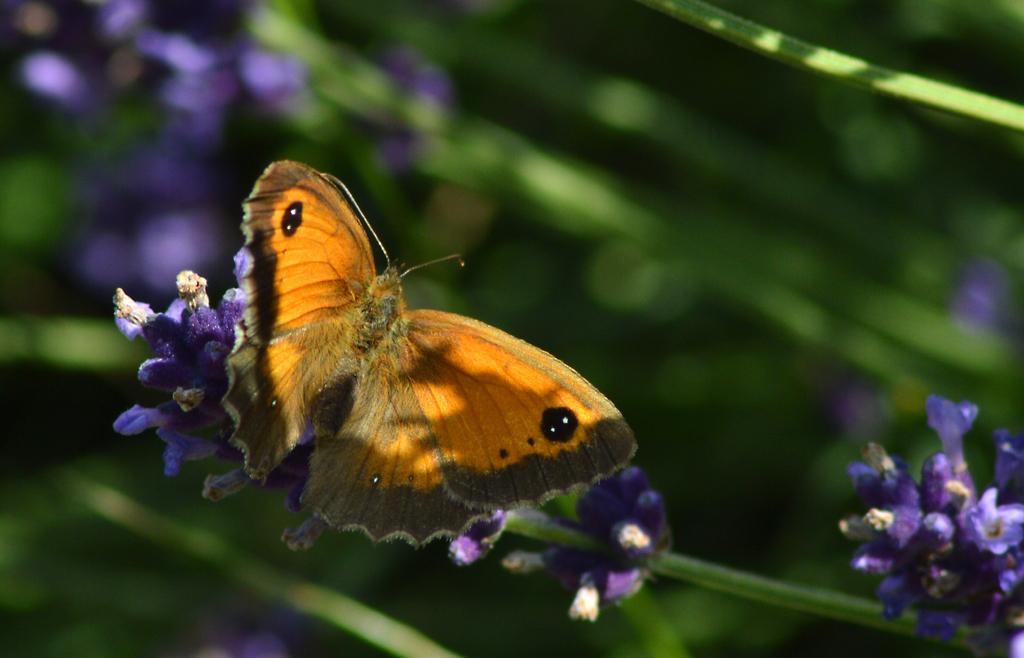In one or two sentences, can you explain what this image depicts? In this image I can see the atoms along with the flowers. On the left side there is a butterfly on the flower. The background is blurred. 